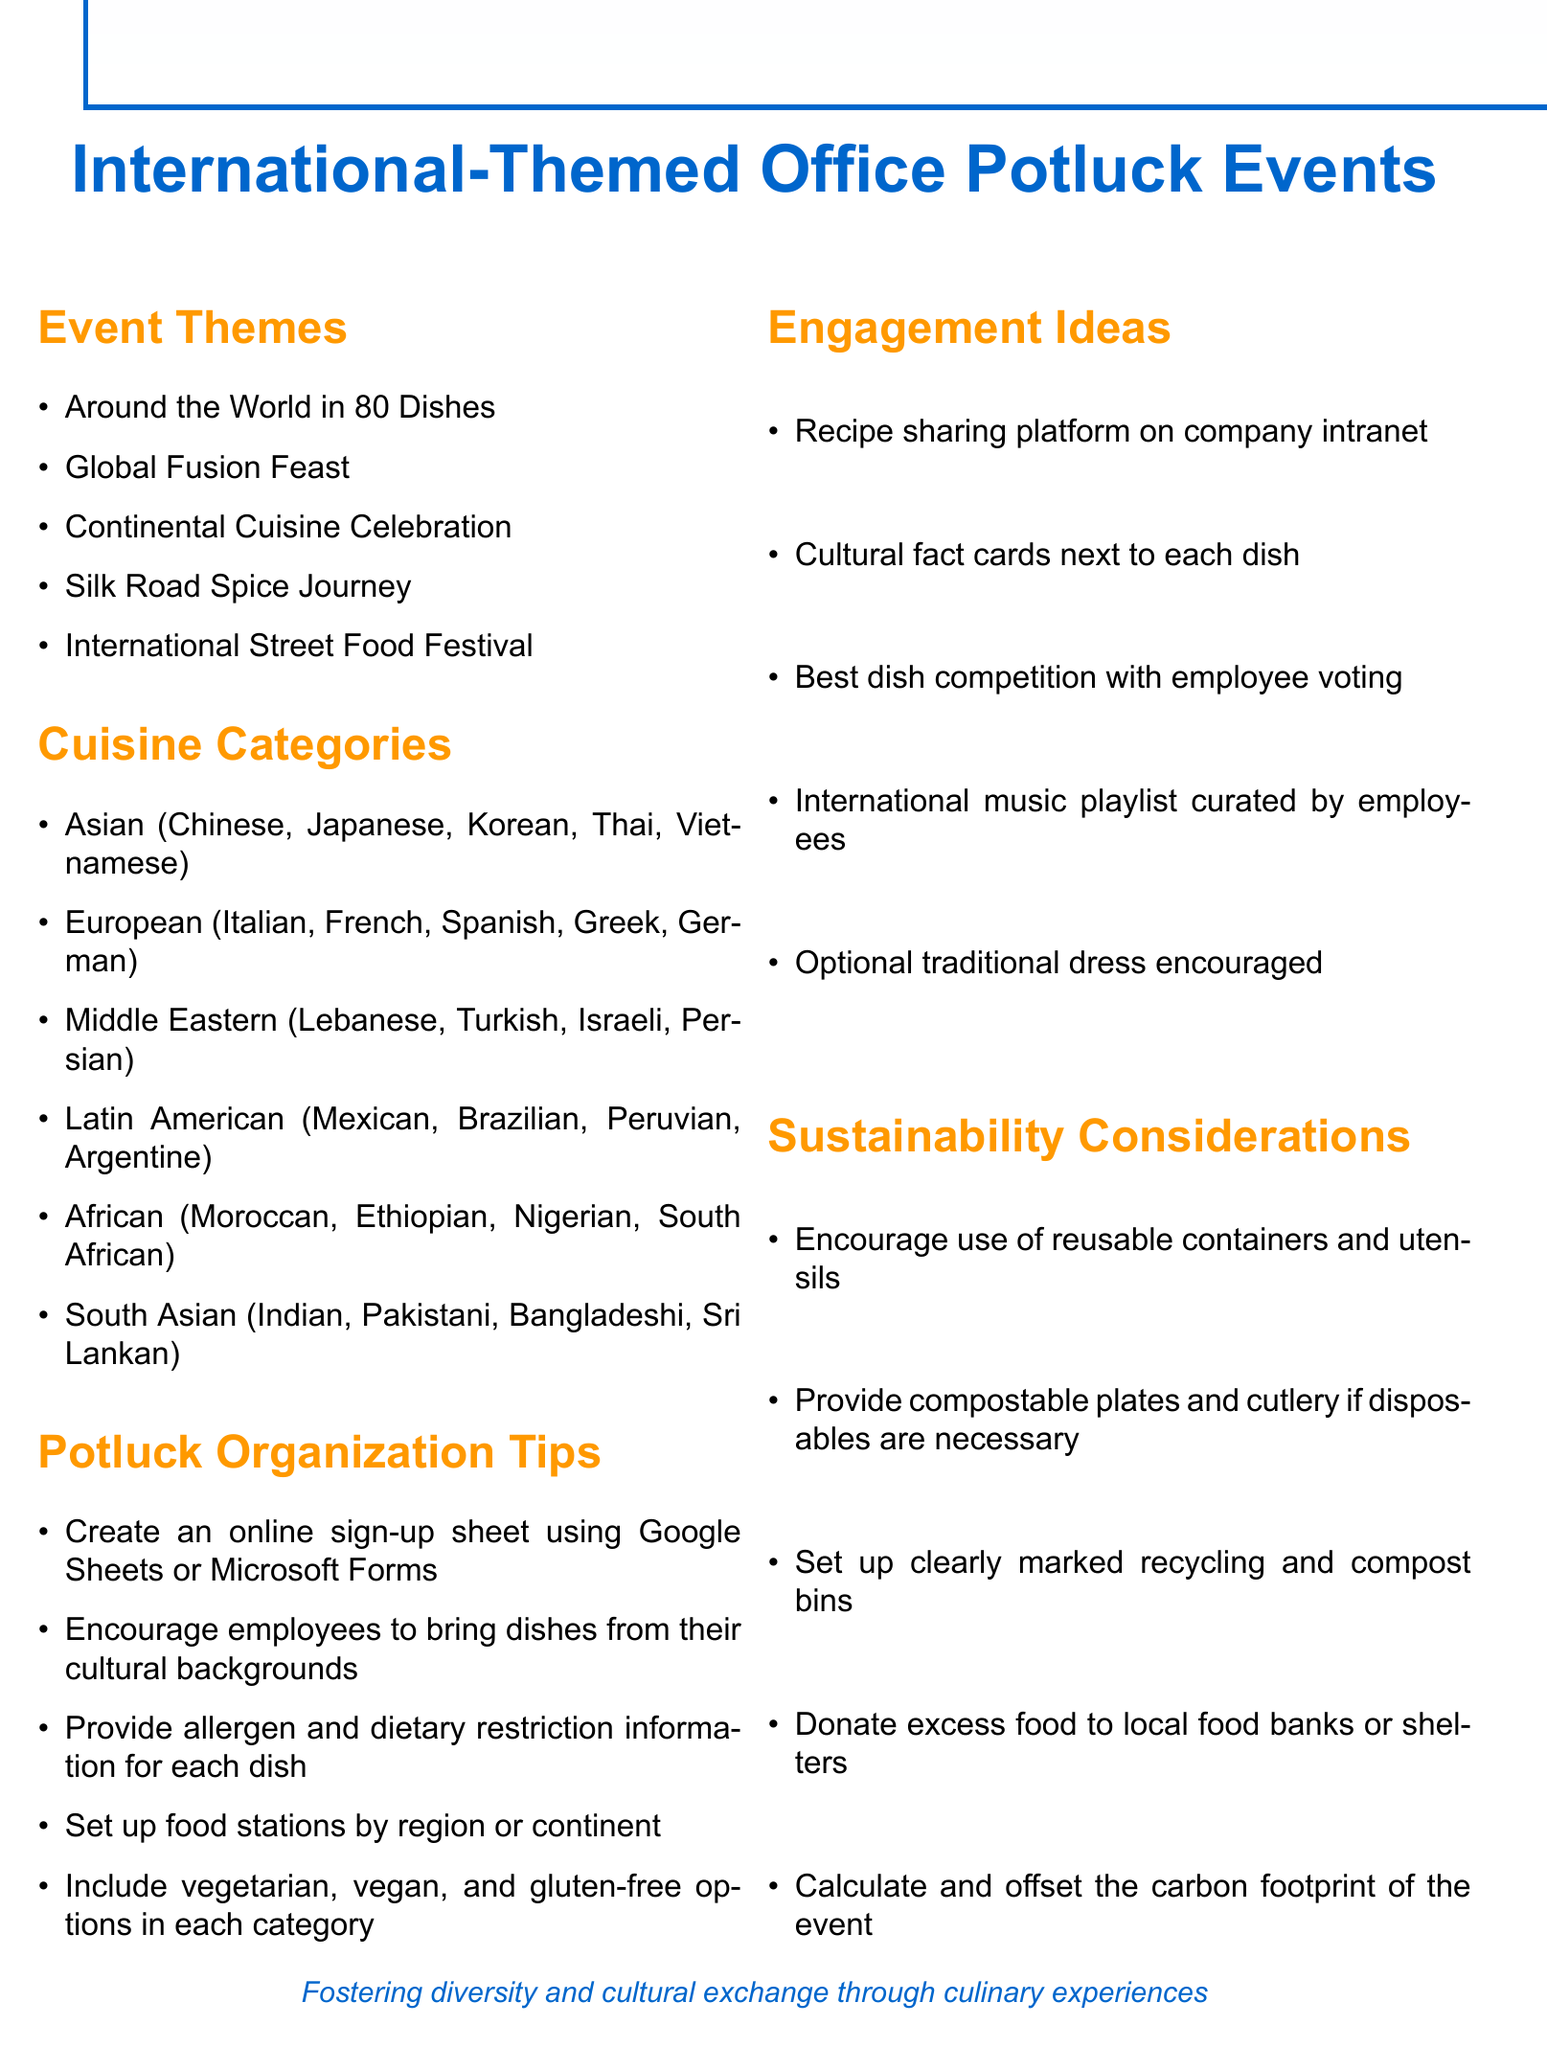What is the theme of the first event listed? The first event theme mentioned is "Around the World in 80 Dishes."
Answer: Around the World in 80 Dishes How many cuisine categories are listed? The document lists a total of six distinct cuisine categories.
Answer: 6 What are the two cuisine categories that include Asian cuisines? The two mentioned are "Asian" and "South Asian."
Answer: Asian, South Asian What is one of the potluck organization tips? One of the tips is to create an online sign-up sheet using Google Sheets or Microsoft Forms.
Answer: Create an online sign-up sheet What engagement idea involves sharing cultural facts? The document suggests including cultural fact cards next to each dish.
Answer: Cultural fact cards What is one sustainability consideration mentioned? One sustainability consideration is to encourage the use of reusable containers and utensils.
Answer: Reusable containers and utensils 